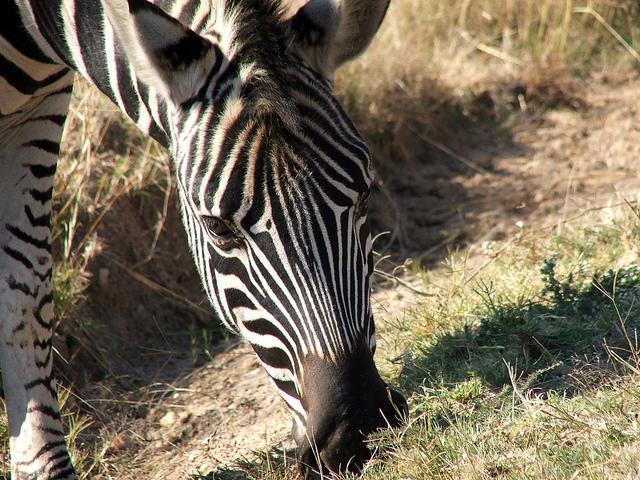How many zebras are in the picture?
Give a very brief answer. 1. How many people are holding a glass of wine?
Give a very brief answer. 0. 